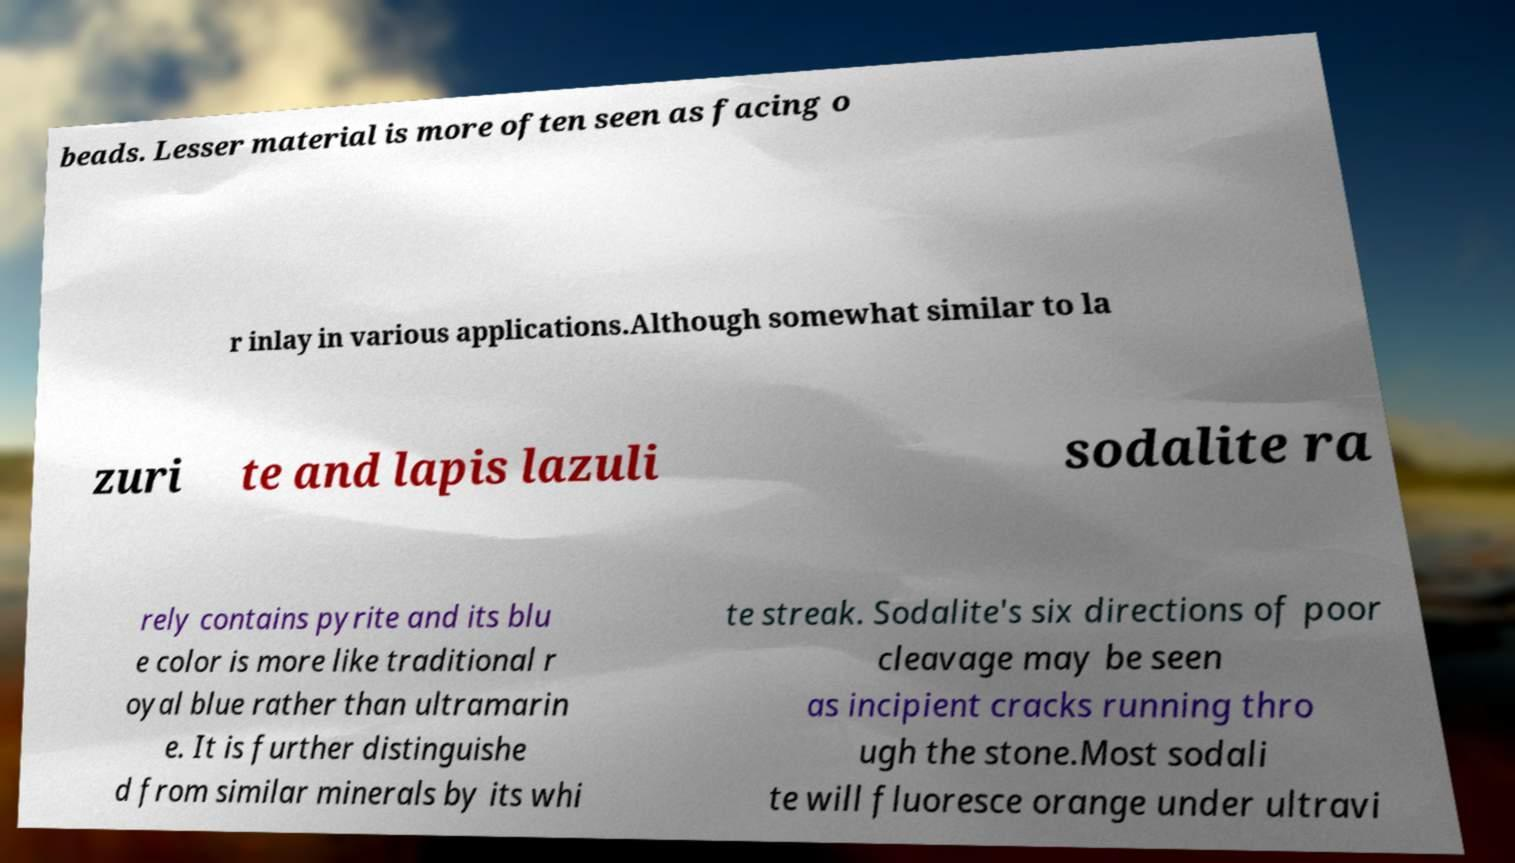There's text embedded in this image that I need extracted. Can you transcribe it verbatim? beads. Lesser material is more often seen as facing o r inlay in various applications.Although somewhat similar to la zuri te and lapis lazuli sodalite ra rely contains pyrite and its blu e color is more like traditional r oyal blue rather than ultramarin e. It is further distinguishe d from similar minerals by its whi te streak. Sodalite's six directions of poor cleavage may be seen as incipient cracks running thro ugh the stone.Most sodali te will fluoresce orange under ultravi 